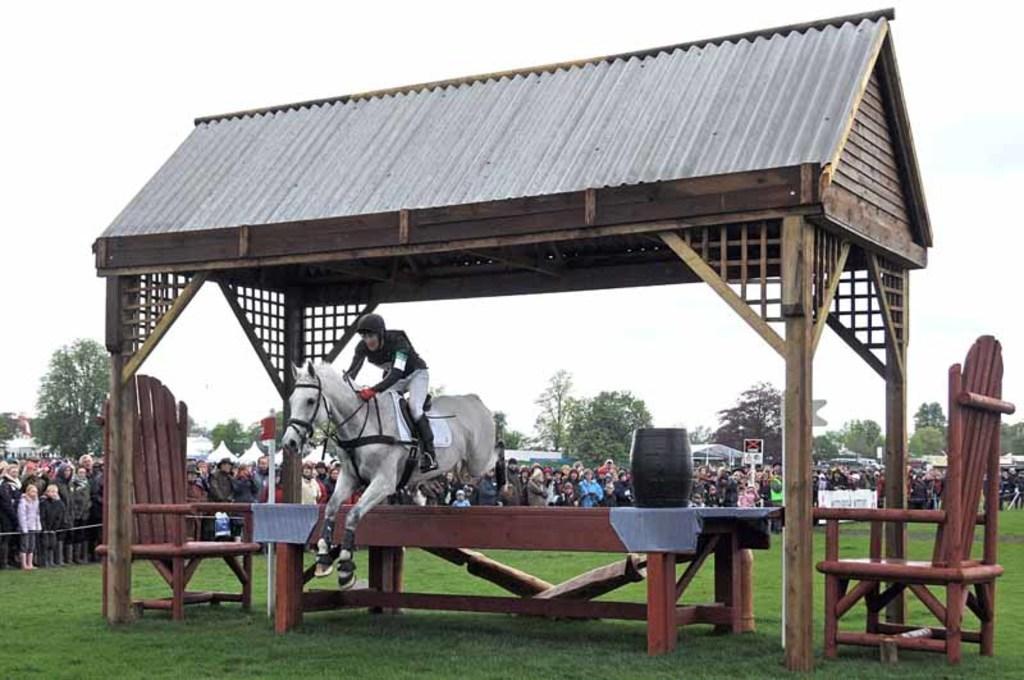Can you describe this image briefly? This picture shows few people standing and watching and we see a man riding a horse and we see horse jumping a table and we see couple of bamboo chairs and a barrel on the table and we see trees and a cloudy sky. 